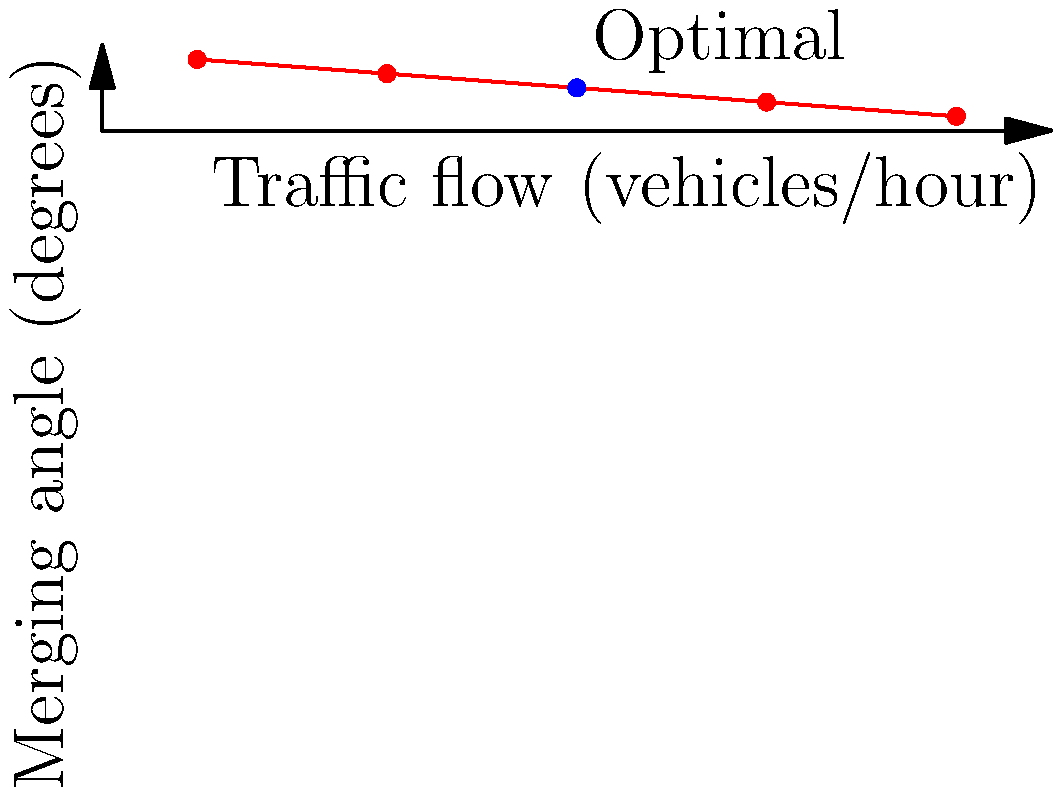Based on the traffic flow chart provided, which shows the relationship between traffic flow and optimal merging angle onto a freeway, what is the recommended merging angle when the traffic flow is approximately 500 vehicles per hour? To determine the optimal merging angle for a traffic flow of 500 vehicles per hour, we need to follow these steps:

1. Locate the point on the x-axis (Traffic flow) corresponding to 500 vehicles/hour.
2. From this point, move vertically up until we intersect the curve on the graph.
3. From the intersection point, move horizontally to the left to read the corresponding value on the y-axis (Merging angle).

Looking at the graph:

1. We can see that 500 vehicles/hour is marked on the x-axis.
2. Moving up from this point, we intersect the curve at the blue dot labeled "Optimal".
3. Moving left from this point to the y-axis, we can read the corresponding angle.

The y-value at this intersection point is 45 degrees.

This relationship shown in the graph indicates that as traffic flow increases, the optimal merging angle decreases. This makes sense because at higher traffic volumes, vehicles need to merge more gradually to safely integrate into the flow of traffic.
Answer: $45^\circ$ 